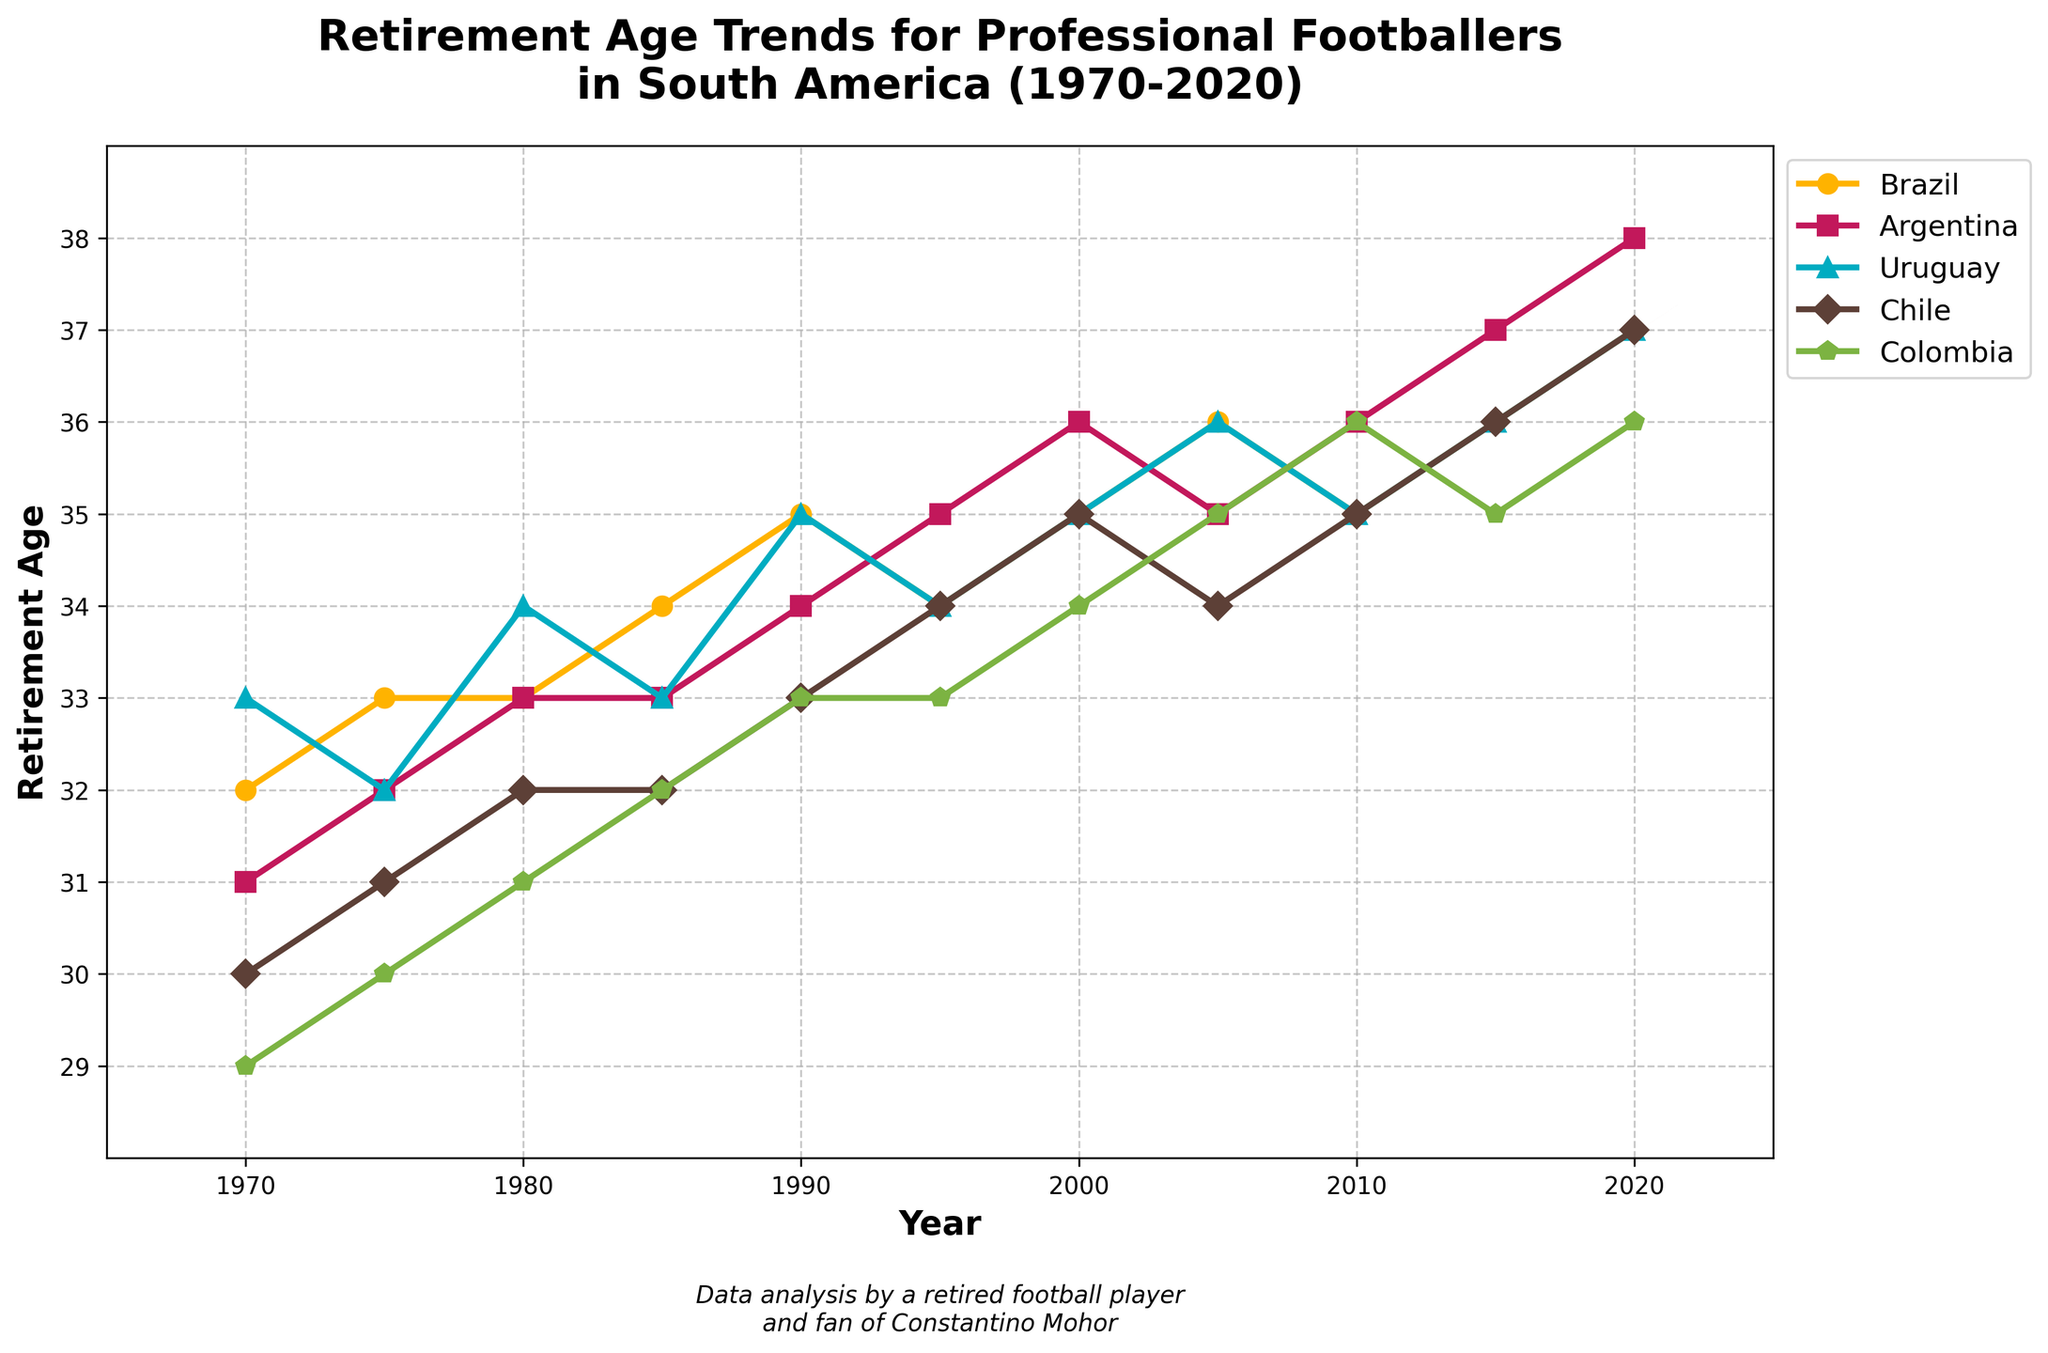What country had the highest average retirement age from 1970 to 2020? To find the answer, sum the retirement ages for each year for each country. Then, divide each total by the number of data points (11). Compare the average values to determine which is the highest.
Answer: Argentina - 34.18 years Did Brazil's retirement age ever decrease from one year to a subsequent year? Check Brazil's retirement ages from 1970 to 2020. Verify each subsequent year to see if any recorded retirement age is lower than the previous year.
Answer: Yes, from 2005 to 2010 Which country showed the most consistent increase in retirement age over the period? Calculate the differences between subsequent years for each country. The country with no decreases in its retirement age and the smallest variation in increments is the most consistent.
Answer: Argentina What is the difference in retirement age between Brazil and Chile in 2020? Subtract Chile's retirement age from Brazil's retirement age in 2020. Brazil: 37, Chile: 37.
Answer: 0 years What is the overall trend in retirement age for Colombian footballers from 1970 to 2020? Observe the retirement age data points for Colombia from 1970 to 2020. Describe the trend based on the direction of the values.
Answer: General increase In which year did Uruguay see its highest retirement age, and what was it? Look at Uruguay's data points from 1970 to 2020. Identify the highest retirement age and the corresponding year.
Answer: 2020, 37 years How many countries had a retirement age of 36 or above in 2010? Check the retirement age values for all countries in 2010. Count how many of these values are 36 or higher.
Answer: 3 countries (Argentina, Brazil, Colombia) What's the average retirement age across all countries in 1980? Calculate the sum of retirement ages for all countries in 1980 and divide by the number of countries (5).
Answer: (33 + 33 + 34 + 32 + 31) / 5 = 32.6 years What was the trend in retirement age for Chile from 2000 to 2020? Observe the retirement age values for Chile from 2000 to 2020. Describe if it generally increased, decreased, or remained steady.
Answer: Increase 